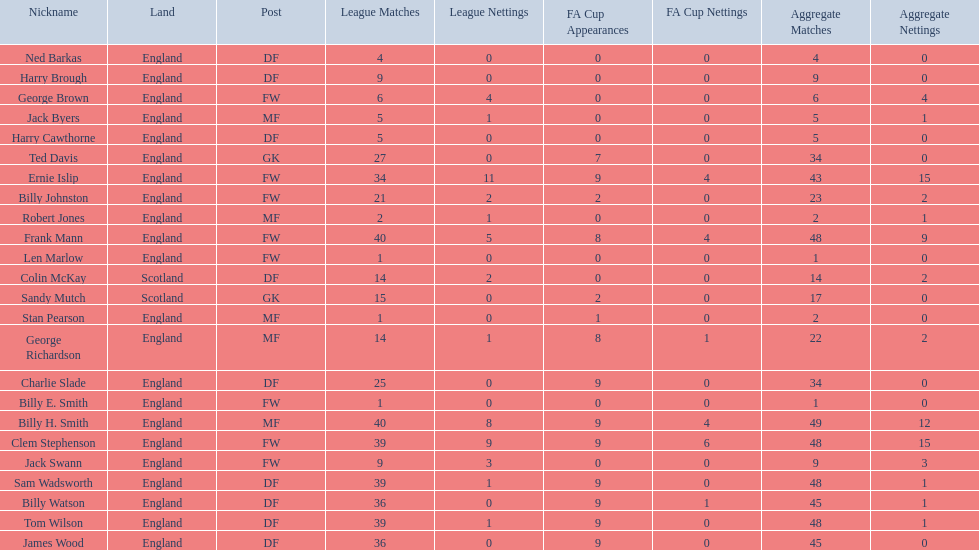Mean count of goals netted by athletes from scotland 1. Could you parse the entire table? {'header': ['Nickname', 'Land', 'Post', 'League Matches', 'League Nettings', 'FA Cup Appearances', 'FA Cup Nettings', 'Aggregate Matches', 'Aggregate Nettings'], 'rows': [['Ned Barkas', 'England', 'DF', '4', '0', '0', '0', '4', '0'], ['Harry Brough', 'England', 'DF', '9', '0', '0', '0', '9', '0'], ['George Brown', 'England', 'FW', '6', '4', '0', '0', '6', '4'], ['Jack Byers', 'England', 'MF', '5', '1', '0', '0', '5', '1'], ['Harry Cawthorne', 'England', 'DF', '5', '0', '0', '0', '5', '0'], ['Ted Davis', 'England', 'GK', '27', '0', '7', '0', '34', '0'], ['Ernie Islip', 'England', 'FW', '34', '11', '9', '4', '43', '15'], ['Billy Johnston', 'England', 'FW', '21', '2', '2', '0', '23', '2'], ['Robert Jones', 'England', 'MF', '2', '1', '0', '0', '2', '1'], ['Frank Mann', 'England', 'FW', '40', '5', '8', '4', '48', '9'], ['Len Marlow', 'England', 'FW', '1', '0', '0', '0', '1', '0'], ['Colin McKay', 'Scotland', 'DF', '14', '2', '0', '0', '14', '2'], ['Sandy Mutch', 'Scotland', 'GK', '15', '0', '2', '0', '17', '0'], ['Stan Pearson', 'England', 'MF', '1', '0', '1', '0', '2', '0'], ['George Richardson', 'England', 'MF', '14', '1', '8', '1', '22', '2'], ['Charlie Slade', 'England', 'DF', '25', '0', '9', '0', '34', '0'], ['Billy E. Smith', 'England', 'FW', '1', '0', '0', '0', '1', '0'], ['Billy H. Smith', 'England', 'MF', '40', '8', '9', '4', '49', '12'], ['Clem Stephenson', 'England', 'FW', '39', '9', '9', '6', '48', '15'], ['Jack Swann', 'England', 'FW', '9', '3', '0', '0', '9', '3'], ['Sam Wadsworth', 'England', 'DF', '39', '1', '9', '0', '48', '1'], ['Billy Watson', 'England', 'DF', '36', '0', '9', '1', '45', '1'], ['Tom Wilson', 'England', 'DF', '39', '1', '9', '0', '48', '1'], ['James Wood', 'England', 'DF', '36', '0', '9', '0', '45', '0']]} 